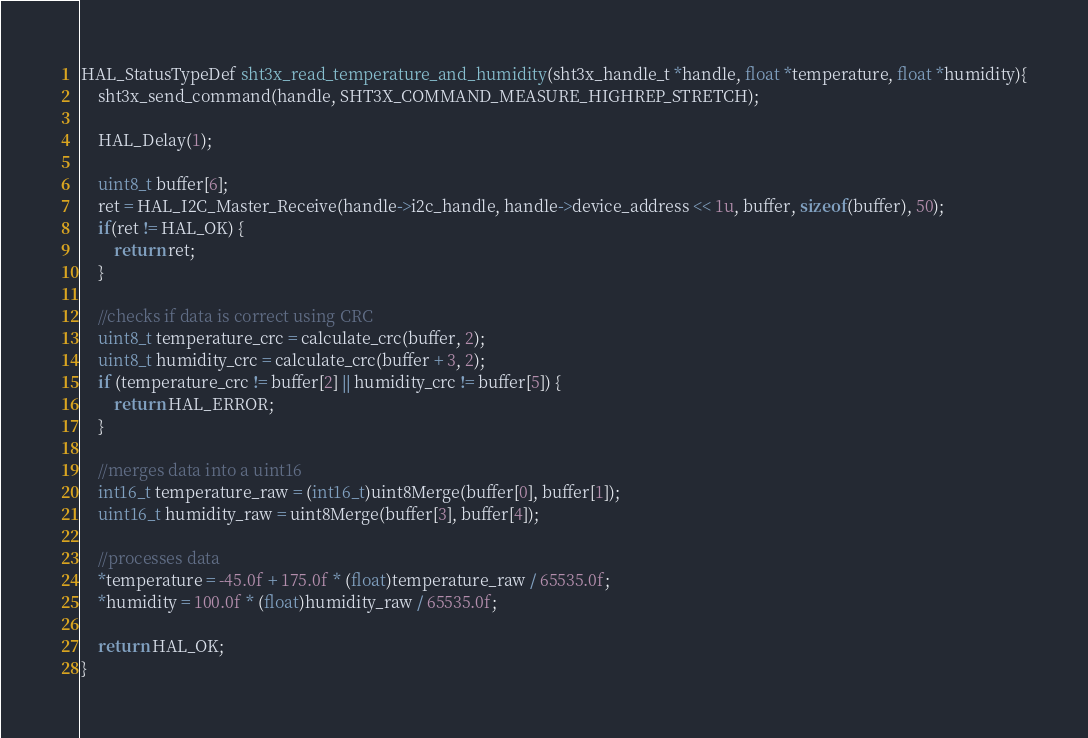Convert code to text. <code><loc_0><loc_0><loc_500><loc_500><_C_>
HAL_StatusTypeDef sht3x_read_temperature_and_humidity(sht3x_handle_t *handle, float *temperature, float *humidity){
	sht3x_send_command(handle, SHT3X_COMMAND_MEASURE_HIGHREP_STRETCH);

	HAL_Delay(1);

	uint8_t buffer[6];
	ret = HAL_I2C_Master_Receive(handle->i2c_handle, handle->device_address << 1u, buffer, sizeof(buffer), 50);
	if(ret != HAL_OK) {
		return ret;
	}

	//checks if data is correct using CRC
	uint8_t temperature_crc = calculate_crc(buffer, 2);
	uint8_t humidity_crc = calculate_crc(buffer + 3, 2);
	if (temperature_crc != buffer[2] || humidity_crc != buffer[5]) {
		return HAL_ERROR;
	}

	//merges data into a uint16
	int16_t temperature_raw = (int16_t)uint8Merge(buffer[0], buffer[1]);
	uint16_t humidity_raw = uint8Merge(buffer[3], buffer[4]);

	//processes data
	*temperature = -45.0f + 175.0f * (float)temperature_raw / 65535.0f;
	*humidity = 100.0f * (float)humidity_raw / 65535.0f;

	return HAL_OK;
}
</code> 